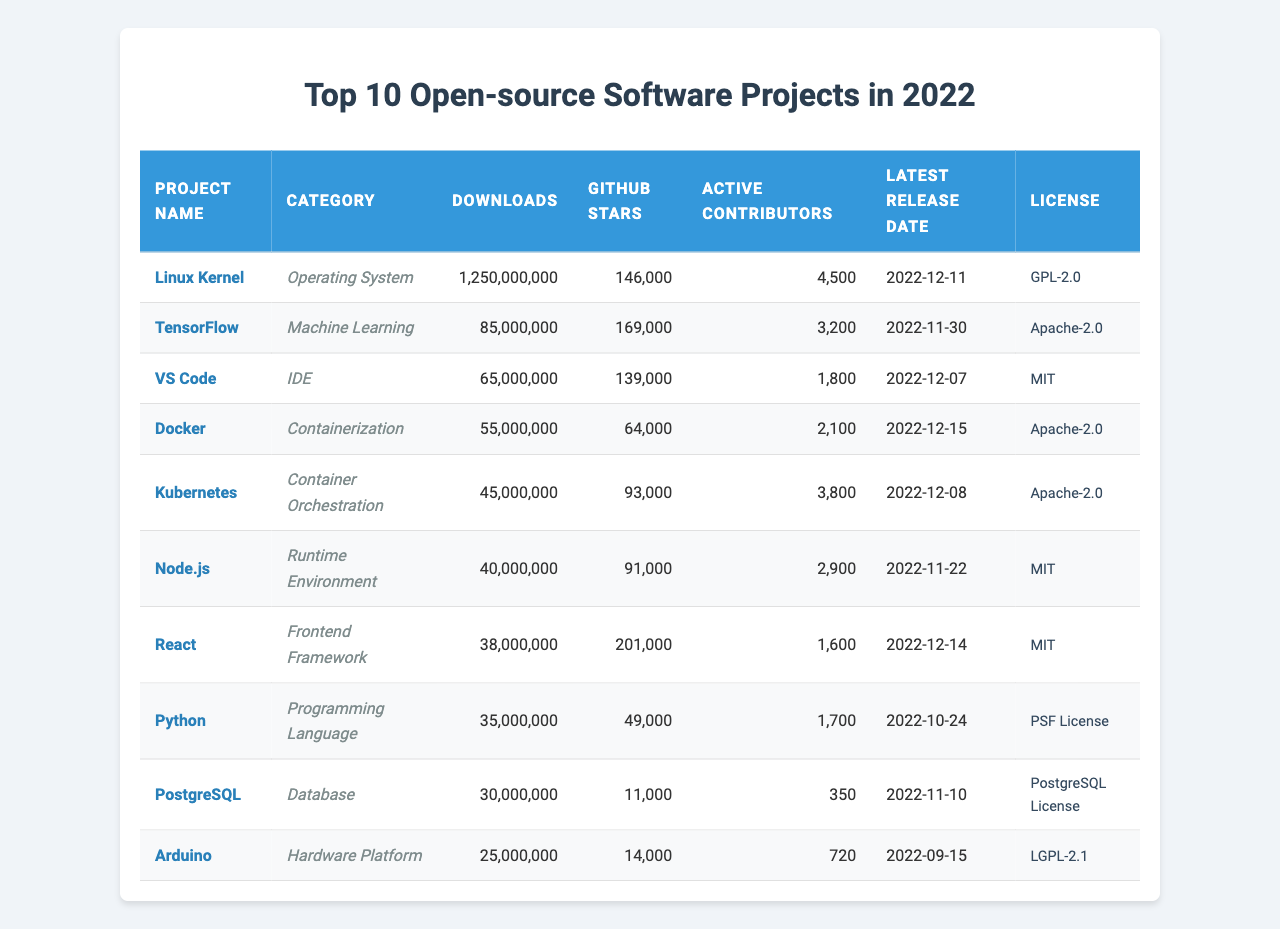What is the project with the highest number of downloads? The project "Linux Kernel" has the highest downloads with a total of 1,250,000,000.
Answer: Linux Kernel How many GitHub stars does TensorFlow have? TensorFlow has 169,000 GitHub stars.
Answer: 169,000 Which project has the lowest number of active contributors? The project "PostgreSQL" has the lowest number of active contributors, with a total of 350.
Answer: 350 Is Docker more popular than Kubernetes in terms of downloads? Yes, Docker has 55,000,000 downloads, which is higher than Kubernetes' 45,000,000 downloads.
Answer: Yes What is the total number of downloads for the top three projects? The total number of downloads is calculated as follows: 1,250,000,000 (Linux Kernel) + 85,000,000 (TensorFlow) + 65,000,000 (VS Code) = 1,400,000,000.
Answer: 1,400,000,000 Which project has the latest release date? The project "Docker" has the latest release date of December 15, 2022.
Answer: Docker If we categorize projects by their categories, how many projects are there in "Containerization"? There is 1 project in the “Containerization” category, which is Docker.
Answer: 1 What is the difference in downloads between React and Python? React has 38,000,000 downloads, and Python has 35,000,000 downloads; the difference is 38,000,000 - 35,000,000 = 3,000,000.
Answer: 3,000,000 How many projects use the Apache-2.0 license? There are three projects using the Apache-2.0 license: TensorFlow, Docker, and Kubernetes.
Answer: 3 Which IDE has fewer downloads, VS Code or Docker? VS Code has 65,000,000 downloads while Docker has 55,000,000 downloads, so Docker has fewer downloads.
Answer: Docker 